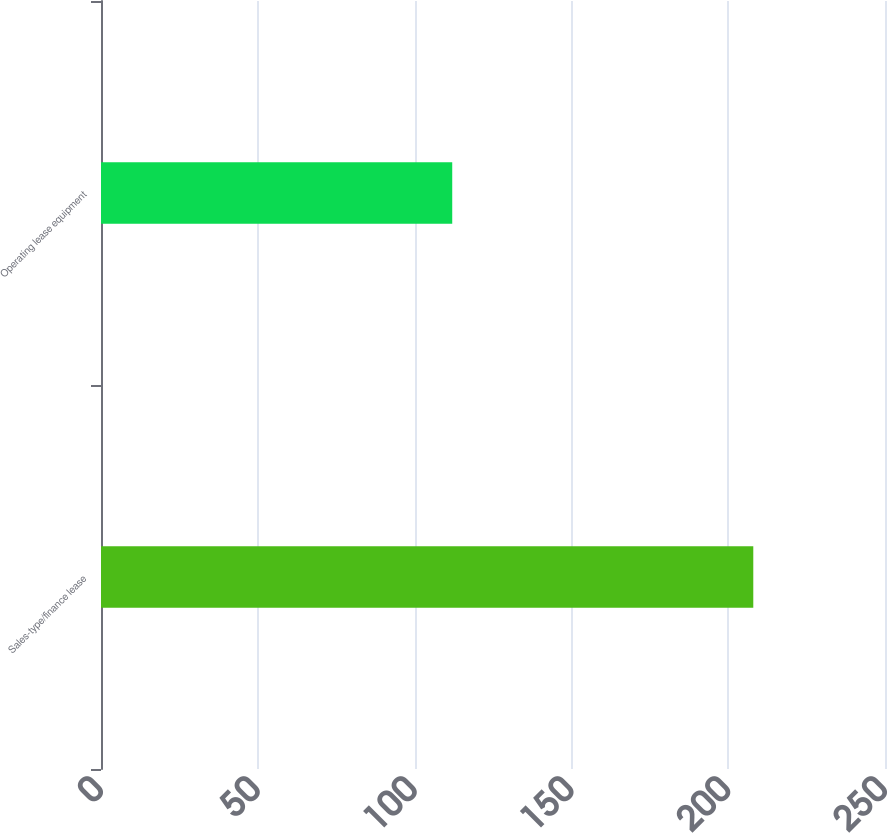<chart> <loc_0><loc_0><loc_500><loc_500><bar_chart><fcel>Sales-type/finance lease<fcel>Operating lease equipment<nl><fcel>208<fcel>112<nl></chart> 